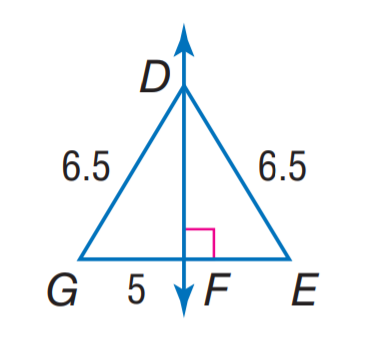Question: Find E G.
Choices:
A. 5
B. 6.5
C. 10
D. 13
Answer with the letter. Answer: C 